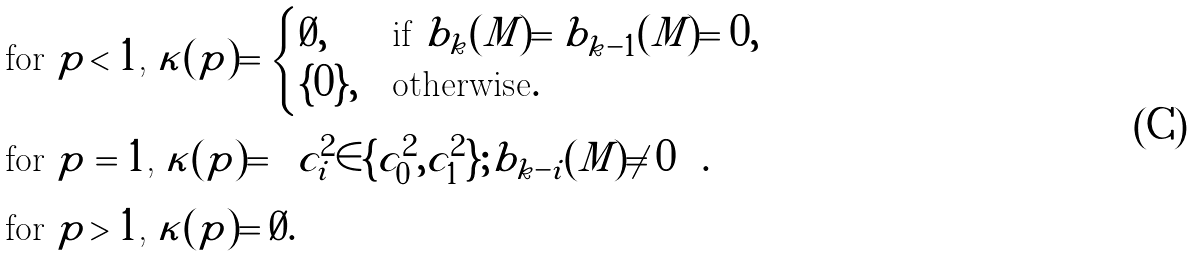<formula> <loc_0><loc_0><loc_500><loc_500>& \text {for $p<1$, } \kappa ( p ) = \begin{cases} \emptyset , & \text {if $b_{k}(M)=b_{k-1}(M)=0$} , \\ \{ 0 \} , & \text {otherwise} . \\ \end{cases} \\ & \text {for $p=1$, } \kappa ( p ) = \left \{ c _ { i } ^ { 2 } \in \{ c _ { 0 } ^ { 2 } , c _ { 1 } ^ { 2 } \} ; b _ { k - i } ( M ) \neq 0 \right \} . \\ & \text {for $p>1$, } \kappa ( p ) = \emptyset .</formula> 